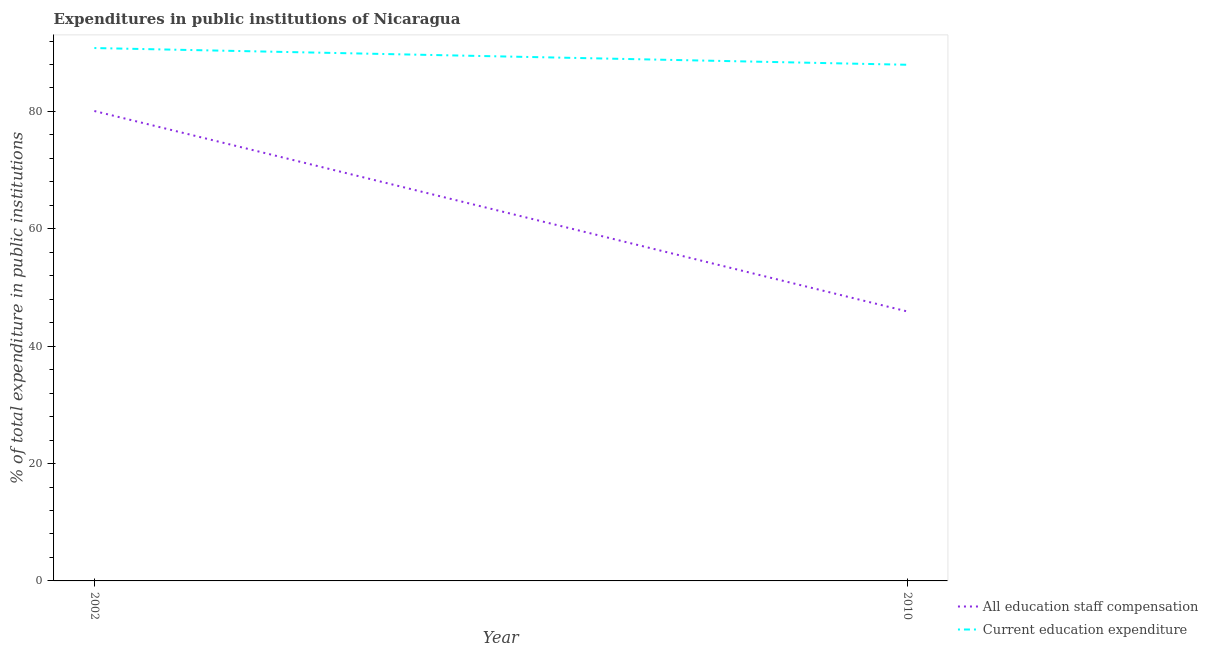Does the line corresponding to expenditure in education intersect with the line corresponding to expenditure in staff compensation?
Make the answer very short. No. Is the number of lines equal to the number of legend labels?
Keep it short and to the point. Yes. What is the expenditure in staff compensation in 2010?
Your answer should be very brief. 45.92. Across all years, what is the maximum expenditure in staff compensation?
Your response must be concise. 80.07. Across all years, what is the minimum expenditure in education?
Keep it short and to the point. 87.95. In which year was the expenditure in staff compensation maximum?
Make the answer very short. 2002. What is the total expenditure in staff compensation in the graph?
Give a very brief answer. 125.99. What is the difference between the expenditure in education in 2002 and that in 2010?
Give a very brief answer. 2.85. What is the difference between the expenditure in education in 2002 and the expenditure in staff compensation in 2010?
Make the answer very short. 44.89. What is the average expenditure in education per year?
Offer a terse response. 89.38. In the year 2002, what is the difference between the expenditure in staff compensation and expenditure in education?
Keep it short and to the point. -10.73. What is the ratio of the expenditure in staff compensation in 2002 to that in 2010?
Provide a succinct answer. 1.74. Is the expenditure in education in 2002 less than that in 2010?
Ensure brevity in your answer.  No. Is the expenditure in education strictly greater than the expenditure in staff compensation over the years?
Provide a succinct answer. Yes. How many years are there in the graph?
Give a very brief answer. 2. What is the difference between two consecutive major ticks on the Y-axis?
Make the answer very short. 20. Where does the legend appear in the graph?
Give a very brief answer. Bottom right. How many legend labels are there?
Your answer should be very brief. 2. What is the title of the graph?
Offer a very short reply. Expenditures in public institutions of Nicaragua. Does "Crop" appear as one of the legend labels in the graph?
Your answer should be compact. No. What is the label or title of the Y-axis?
Make the answer very short. % of total expenditure in public institutions. What is the % of total expenditure in public institutions of All education staff compensation in 2002?
Keep it short and to the point. 80.07. What is the % of total expenditure in public institutions of Current education expenditure in 2002?
Give a very brief answer. 90.8. What is the % of total expenditure in public institutions in All education staff compensation in 2010?
Keep it short and to the point. 45.92. What is the % of total expenditure in public institutions in Current education expenditure in 2010?
Offer a terse response. 87.95. Across all years, what is the maximum % of total expenditure in public institutions of All education staff compensation?
Offer a terse response. 80.07. Across all years, what is the maximum % of total expenditure in public institutions in Current education expenditure?
Ensure brevity in your answer.  90.8. Across all years, what is the minimum % of total expenditure in public institutions in All education staff compensation?
Keep it short and to the point. 45.92. Across all years, what is the minimum % of total expenditure in public institutions in Current education expenditure?
Provide a succinct answer. 87.95. What is the total % of total expenditure in public institutions of All education staff compensation in the graph?
Offer a terse response. 125.99. What is the total % of total expenditure in public institutions of Current education expenditure in the graph?
Offer a very short reply. 178.76. What is the difference between the % of total expenditure in public institutions of All education staff compensation in 2002 and that in 2010?
Offer a terse response. 34.16. What is the difference between the % of total expenditure in public institutions in Current education expenditure in 2002 and that in 2010?
Ensure brevity in your answer.  2.85. What is the difference between the % of total expenditure in public institutions of All education staff compensation in 2002 and the % of total expenditure in public institutions of Current education expenditure in 2010?
Your answer should be very brief. -7.88. What is the average % of total expenditure in public institutions of All education staff compensation per year?
Offer a very short reply. 63. What is the average % of total expenditure in public institutions in Current education expenditure per year?
Give a very brief answer. 89.38. In the year 2002, what is the difference between the % of total expenditure in public institutions in All education staff compensation and % of total expenditure in public institutions in Current education expenditure?
Make the answer very short. -10.73. In the year 2010, what is the difference between the % of total expenditure in public institutions of All education staff compensation and % of total expenditure in public institutions of Current education expenditure?
Your answer should be very brief. -42.04. What is the ratio of the % of total expenditure in public institutions of All education staff compensation in 2002 to that in 2010?
Provide a short and direct response. 1.74. What is the ratio of the % of total expenditure in public institutions of Current education expenditure in 2002 to that in 2010?
Ensure brevity in your answer.  1.03. What is the difference between the highest and the second highest % of total expenditure in public institutions of All education staff compensation?
Your response must be concise. 34.16. What is the difference between the highest and the second highest % of total expenditure in public institutions in Current education expenditure?
Your answer should be very brief. 2.85. What is the difference between the highest and the lowest % of total expenditure in public institutions of All education staff compensation?
Keep it short and to the point. 34.16. What is the difference between the highest and the lowest % of total expenditure in public institutions in Current education expenditure?
Provide a short and direct response. 2.85. 